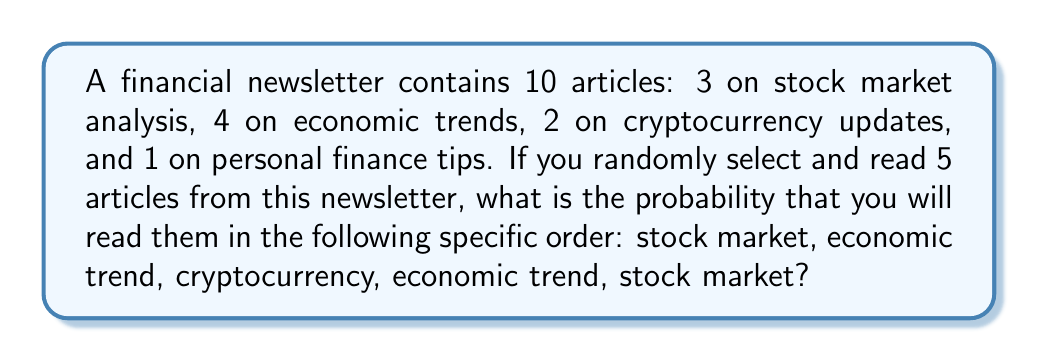Show me your answer to this math problem. To solve this problem, we need to use the multiplication principle of probability. The probability of each event occurring in sequence is multiplied together.

1) For the first article (stock market): 
   Probability = $\frac{3}{10}$

2) For the second article (economic trend): 
   Probability = $\frac{4}{9}$ (9 articles left, 4 are economic trends)

3) For the third article (cryptocurrency): 
   Probability = $\frac{2}{8}$ (8 articles left, 2 are cryptocurrency)

4) For the fourth article (economic trend): 
   Probability = $\frac{3}{7}$ (7 articles left, 3 are economic trends)

5) For the fifth article (stock market): 
   Probability = $\frac{2}{6}$ (6 articles left, 2 are stock market)

The probability of this specific sequence occurring is:

$$P = \frac{3}{10} \times \frac{4}{9} \times \frac{2}{8} \times \frac{3}{7} \times \frac{2}{6}$$

Simplifying:

$$P = \frac{3 \times 4 \times 2 \times 3 \times 2}{10 \times 9 \times 8 \times 7 \times 6} = \frac{144}{30240} = \frac{1}{210}$$
Answer: $\frac{1}{210}$ or approximately 0.00476 (0.476%) 